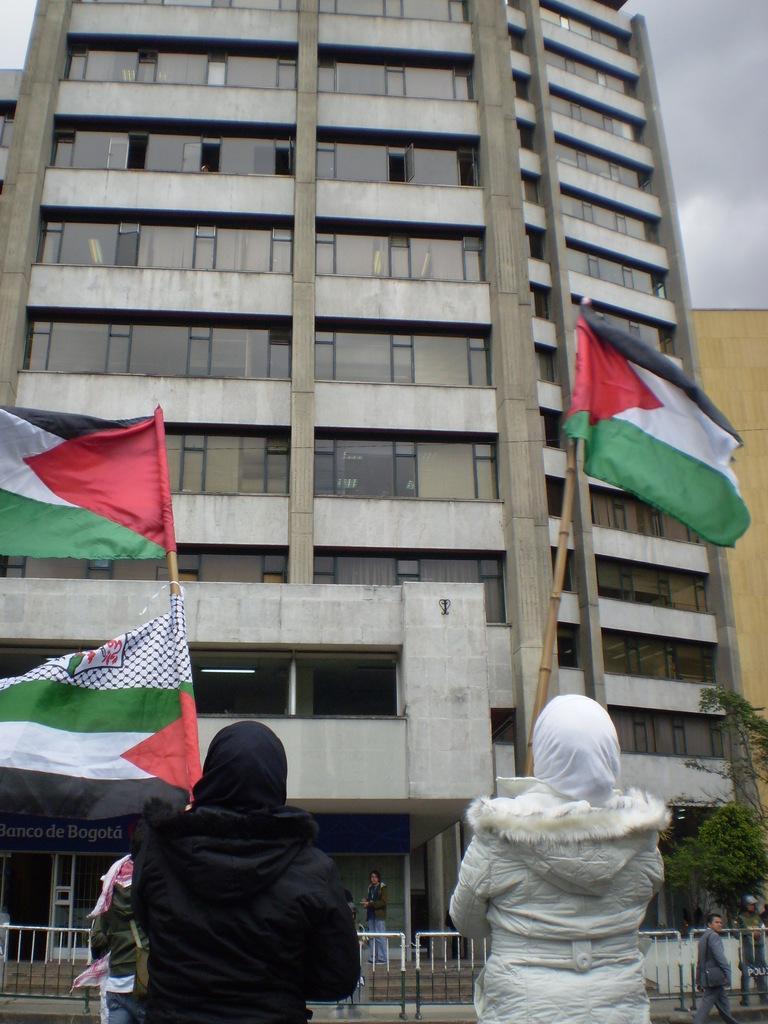Describe this image in one or two sentences. In this image there are two people holding the flags. In front of them there a few people. There is a metal fence. In the background of the image there are buildings, trees and sky. 